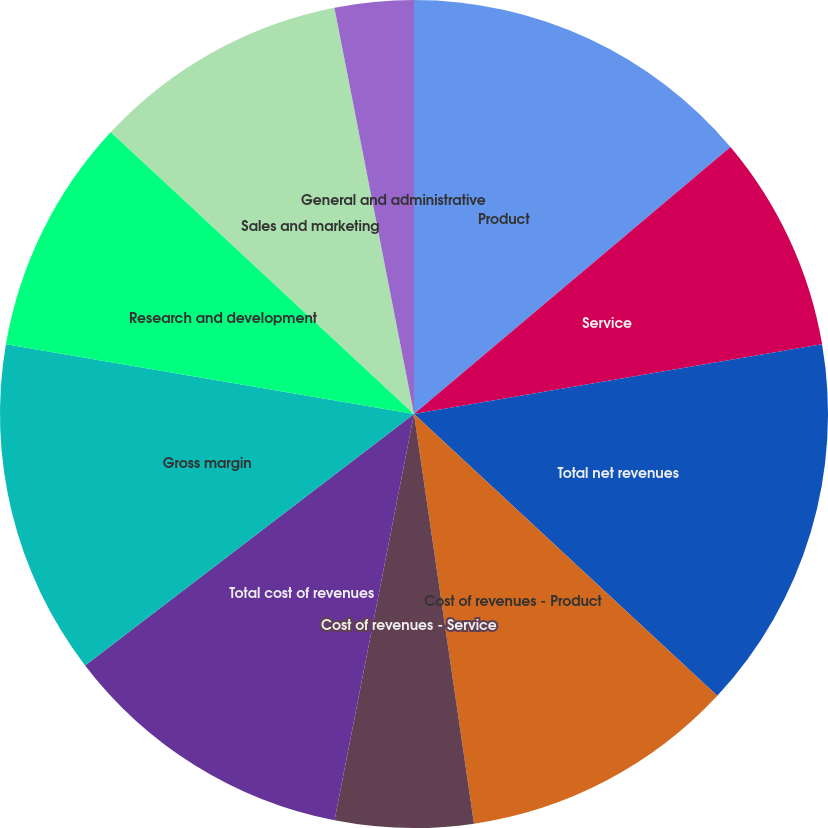Convert chart. <chart><loc_0><loc_0><loc_500><loc_500><pie_chart><fcel>Product<fcel>Service<fcel>Total net revenues<fcel>Cost of revenues - Product<fcel>Cost of revenues - Service<fcel>Total cost of revenues<fcel>Gross margin<fcel>Research and development<fcel>Sales and marketing<fcel>General and administrative<nl><fcel>13.85%<fcel>8.46%<fcel>14.61%<fcel>10.77%<fcel>5.39%<fcel>11.54%<fcel>13.08%<fcel>9.23%<fcel>10.0%<fcel>3.08%<nl></chart> 